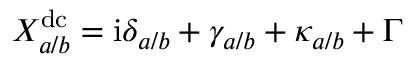<formula> <loc_0><loc_0><loc_500><loc_500>X _ { a / b } ^ { d c } = i \delta _ { a / b } + \gamma _ { a / b } + \kappa _ { a / b } + \Gamma</formula> 